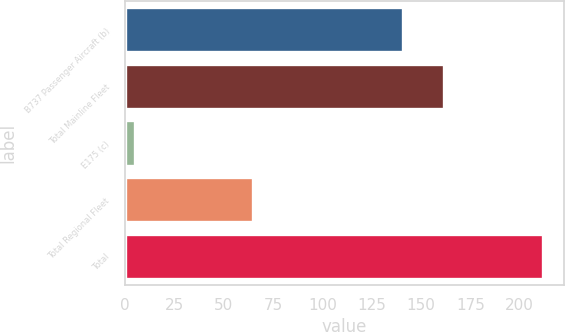Convert chart to OTSL. <chart><loc_0><loc_0><loc_500><loc_500><bar_chart><fcel>B737 Passenger Aircraft (b)<fcel>Total Mainline Fleet<fcel>E175 (c)<fcel>Total Regional Fleet<fcel>Total<nl><fcel>141<fcel>161.7<fcel>5<fcel>65<fcel>212<nl></chart> 